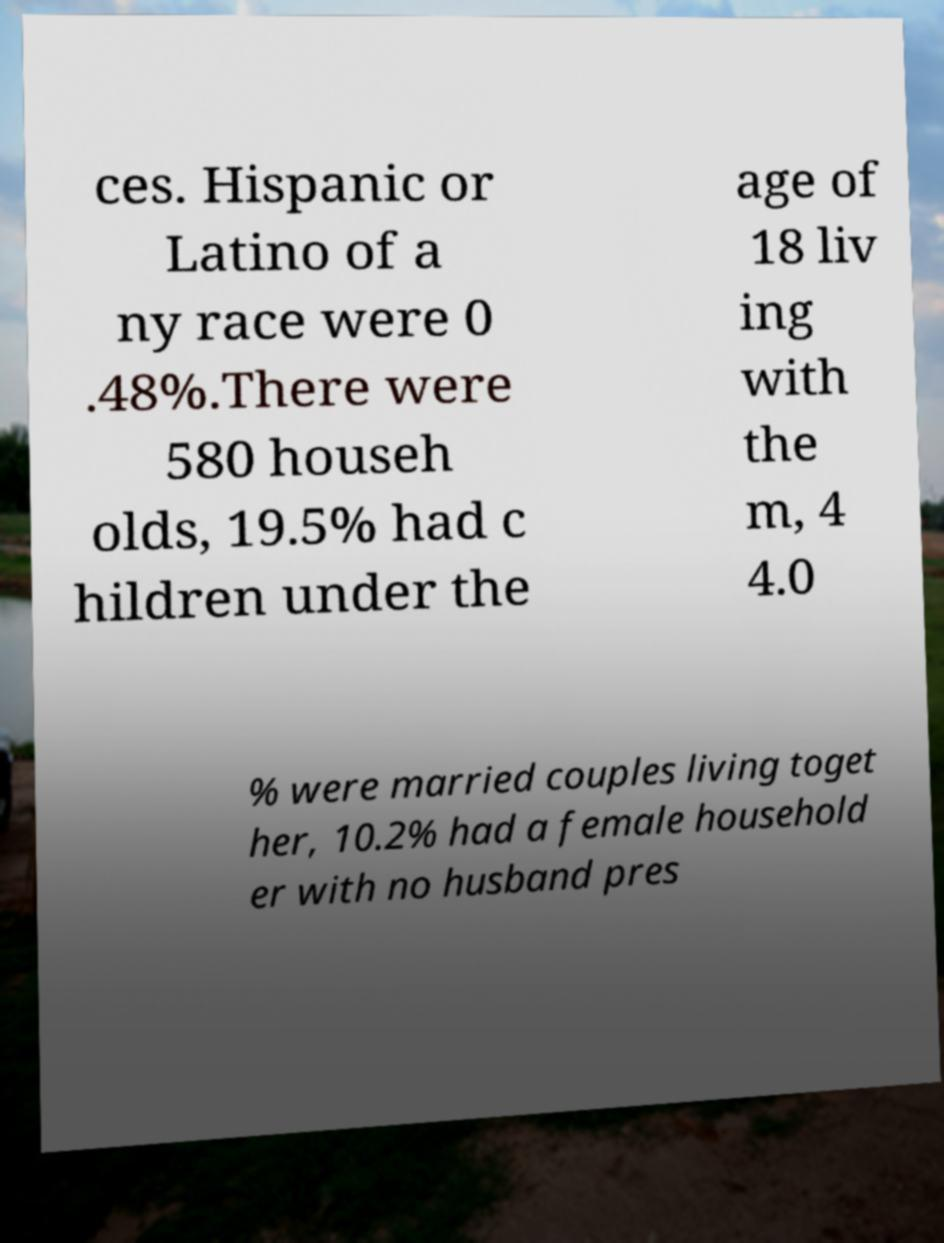Could you extract and type out the text from this image? ces. Hispanic or Latino of a ny race were 0 .48%.There were 580 househ olds, 19.5% had c hildren under the age of 18 liv ing with the m, 4 4.0 % were married couples living toget her, 10.2% had a female household er with no husband pres 